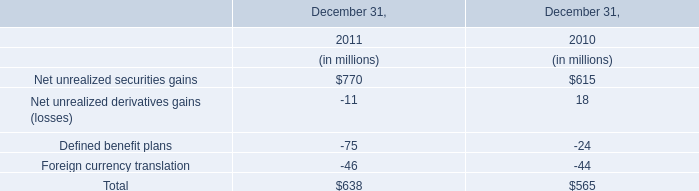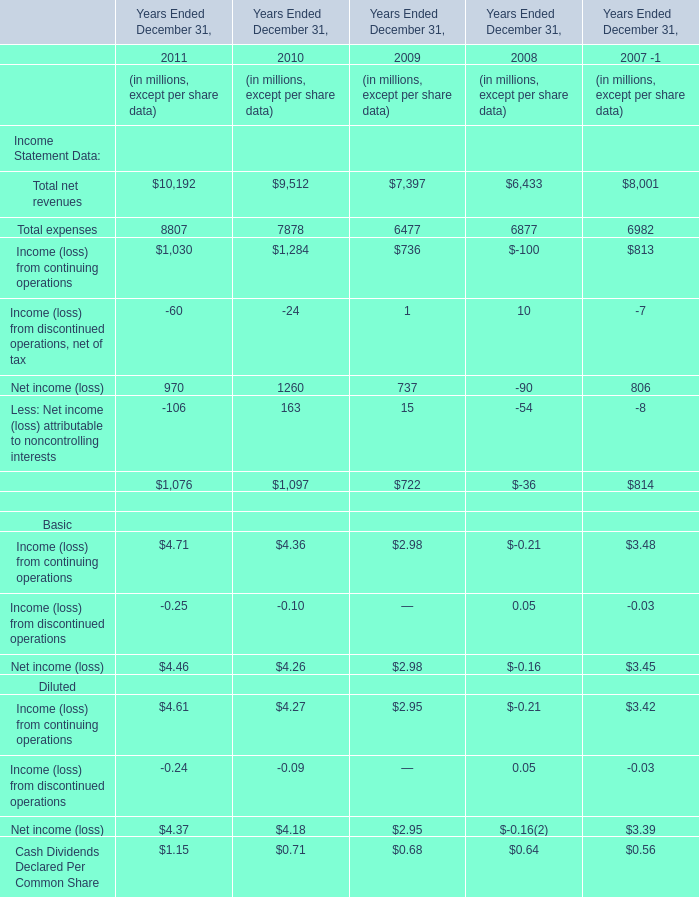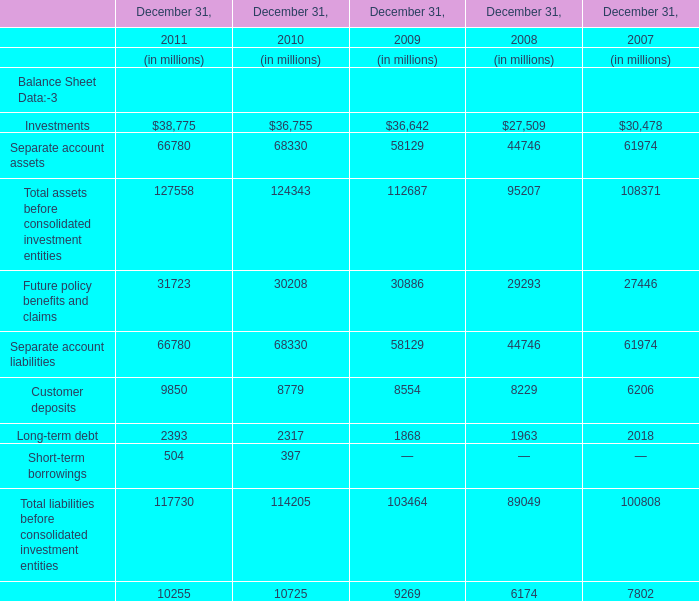In the year with lowest amount of Investments, what's the increasing rate of Separate account assets? 
Computations: ((44746 - 61974) / 61974)
Answer: -0.27799. 